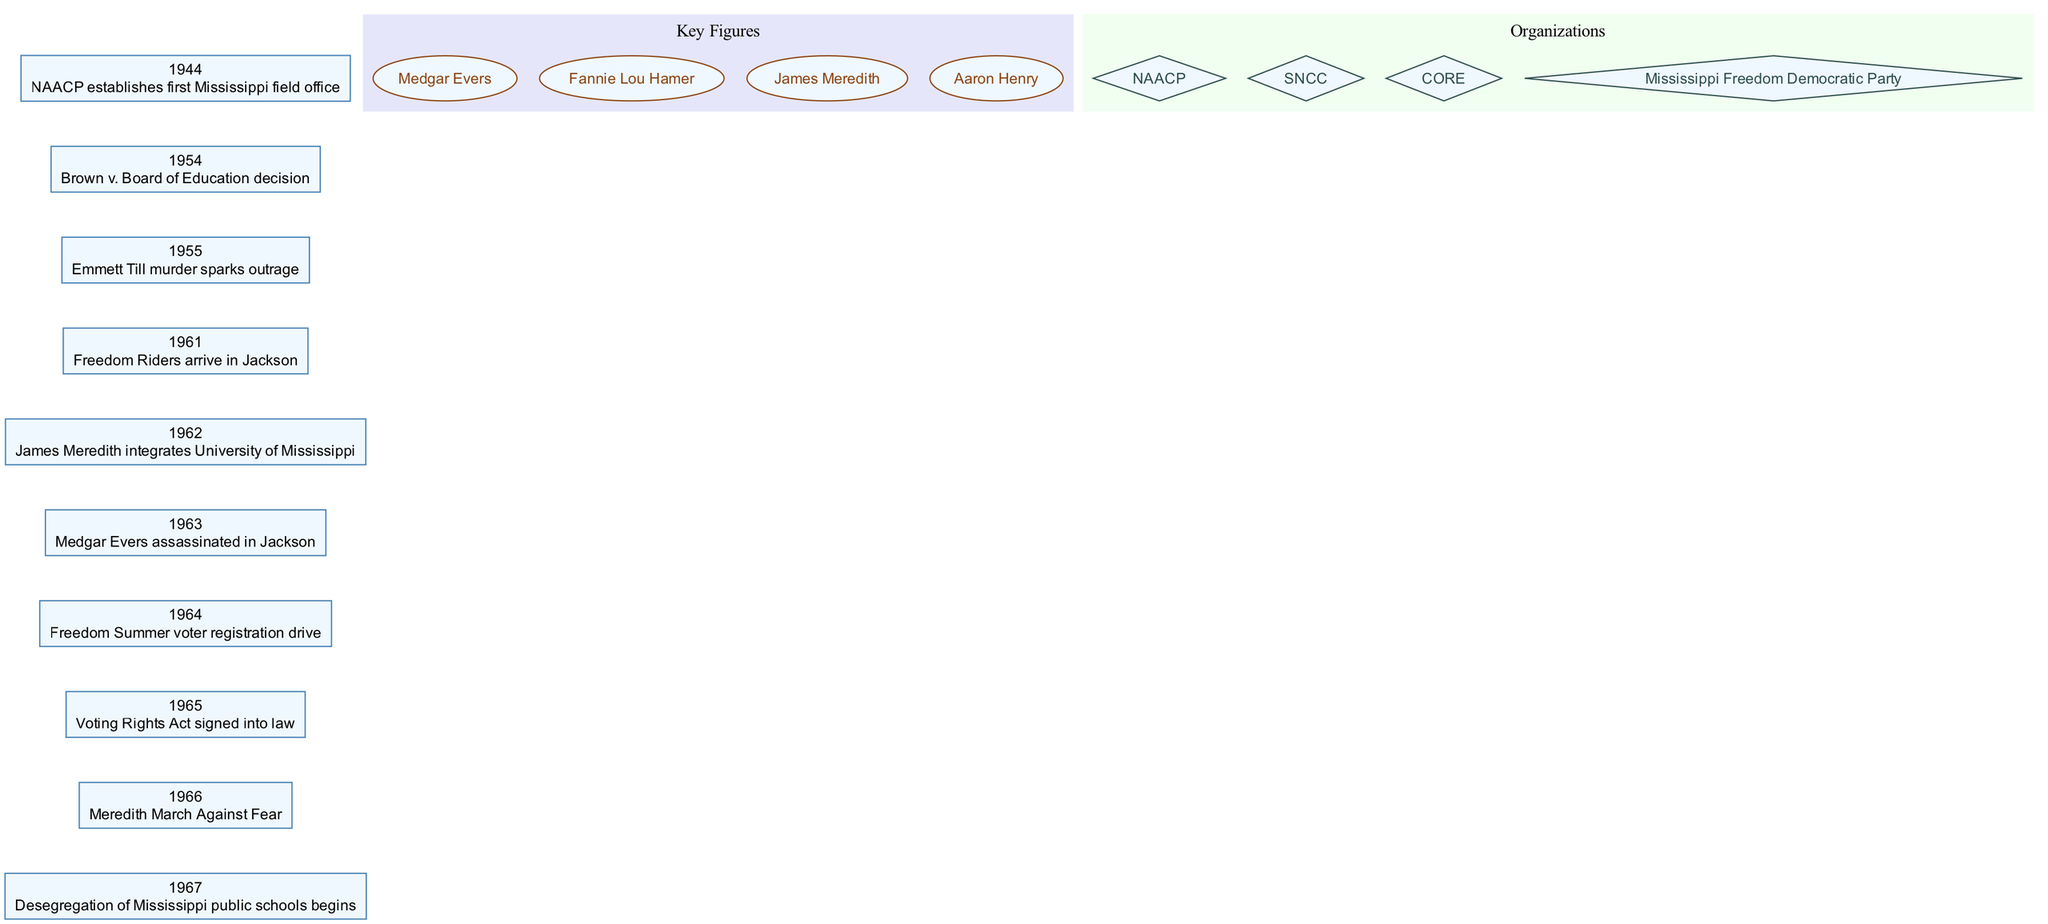What year did the NAACP establish its first Mississippi field office? The diagram shows that the NAACP established its first Mississippi field office in 1944, which is directly indicated in the timeline.
Answer: 1944 How many key figures are listed in the diagram? By counting the entries in the 'Key Figures' section of the diagram, we find there are four named individuals listed: Medgar Evers, Fannie Lou Hamer, James Meredith, and Aaron Henry.
Answer: 4 What event is associated with the year 1963? Looking at the timeline, 1963 is marked with the assassination of Medgar Evers in Jackson, which is specified in the corresponding node.
Answer: Medgar Evers assassinated in Jackson Which organization was involved in the Freedom Summer voter registration drive in 1964? The diagram includes various organizations, notably mentioning the Mississippi Freedom Democratic Party, which was closely associated with the Freedom Summer events.
Answer: Mississippi Freedom Democratic Party What happened in 1965? The diagram indicates that in 1965, the 'Voting Rights Act' was signed into law, which is a significant landmark event specifically noted in the timeline.
Answer: Voting Rights Act signed into law Which event preceded the Brown v. Board of Education decision in the timeline? By examining the diagram, it can be seen that the event preceding the Brown v. Board of Education decision in 1954 is the establishment of the NAACP's first field office in 1944, established a decade earlier.
Answer: NAACP establishes first Mississippi field office Who was the first to integrate the University of Mississippi? The diagram directly names James Meredith as the individual who integrated the University of Mississippi in the year 1962, as highlighted on the timeline.
Answer: James Meredith integrates University of Mississippi What is the significance of the year 1966 in the context of the diagram? The year 1966 is marked by the 'Meredith March Against Fear,' highlighting this as a key event in the civil rights timeline specifically addressed within the diagram.
Answer: Meredith March Against Fear 